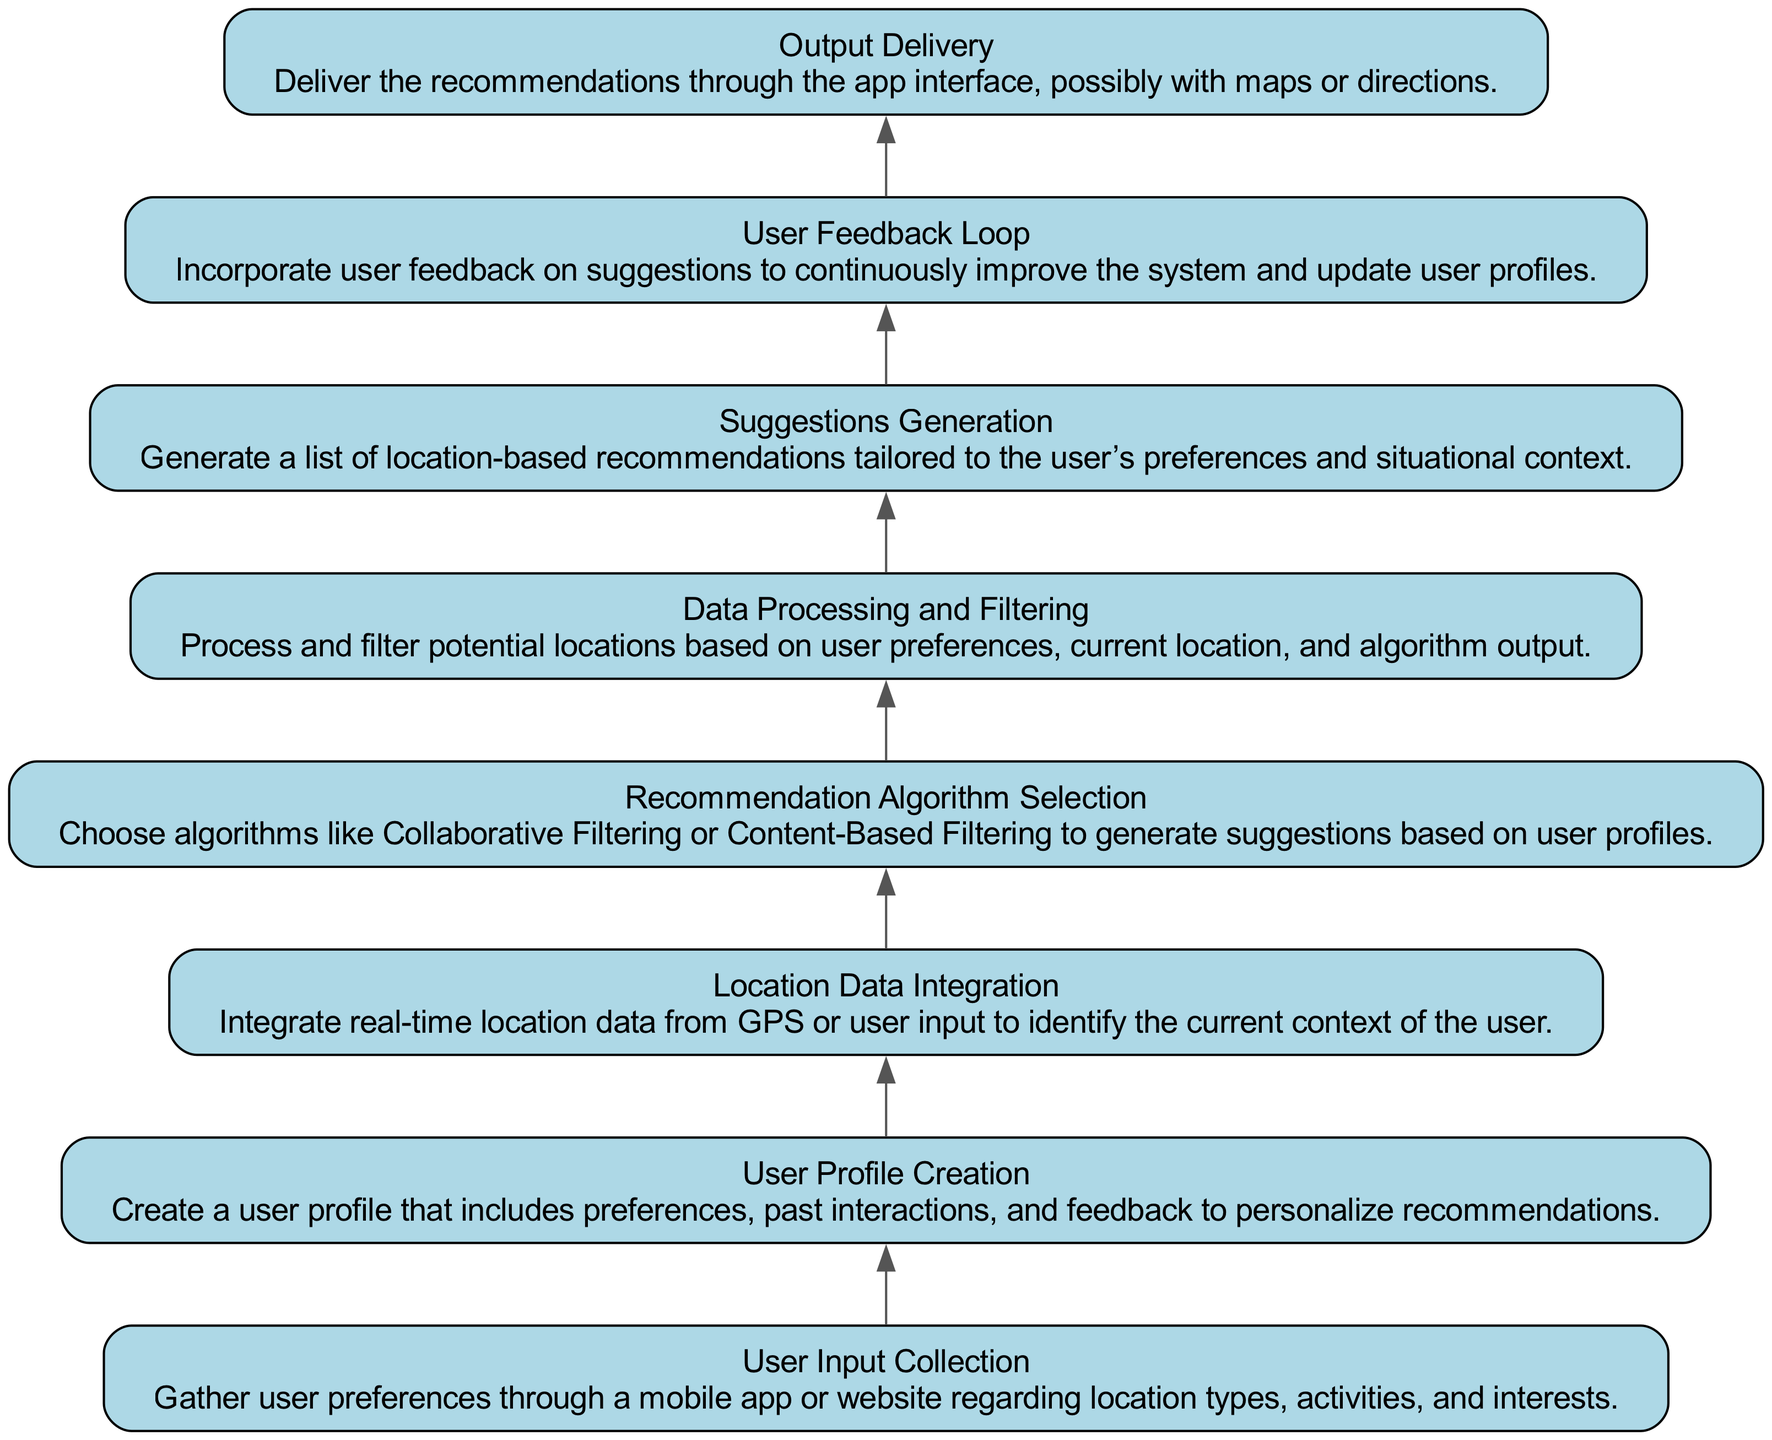What is the first node in the diagram? The first node in the diagram is "User Input Collection", which is the initial step in gathering user preferences.
Answer: User Input Collection How many nodes are there in total? The diagram contains a total of eight nodes that represent different steps in the recommendation system process.
Answer: Eight What is the output of the last node in the flow? The last node states "Output Delivery", which indicates the result of the entire process being delivered to the user.
Answer: Output Delivery Which node comes directly after "User Profile Creation"? Directly after "User Profile Creation", the next node is "Location Data Integration", showing the sequence of operations that follow.
Answer: Location Data Integration What is the relationship between "Suggestions Generation" and "User Feedback Loop"? "Suggestions Generation" is followed by "User Feedback Loop", which means that suggestions are used to gather user feedback to enhance the recommendation system.
Answer: Feedback loop Which two nodes focus on user data? "User Profile Creation" and "User Feedback Loop" are the two nodes that specifically deal with collecting and using user data to improve recommendations.
Answer: User Profile Creation and User Feedback Loop Which recommendation algorithm is mentioned in the diagram? The node "Recommendation Algorithm Selection" mentions algorithms such as Collaborative Filtering or Content-Based Filtering for generating suggestions.
Answer: Collaborative Filtering or Content-Based Filtering What process occurs before "Suggestions Generation"? Before "Suggestions Generation", the process of "Data Processing and Filtering" occurs, which prepares the information needed to create the suggestions.
Answer: Data Processing and Filtering How does the diagram depict the flow of information? The diagram depicts a bottom-up flow where each node leads to the next, indicating a stepwise progression from user input to the delivery of suggestions.
Answer: Stepwise progression 